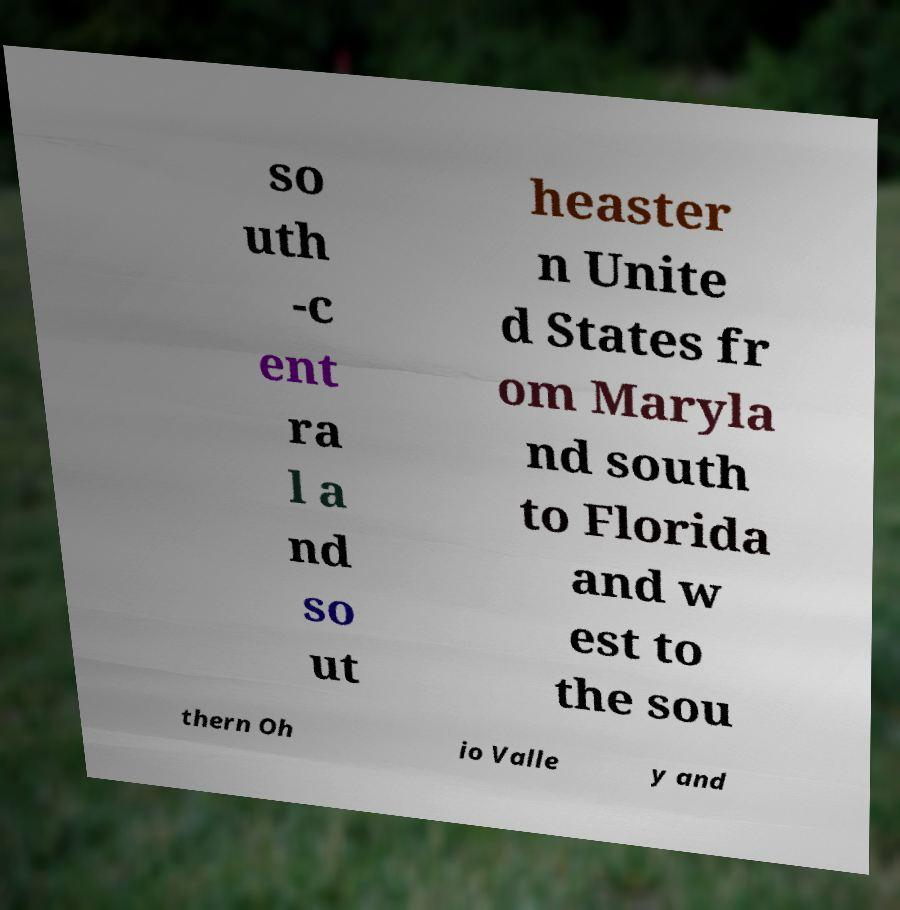What messages or text are displayed in this image? I need them in a readable, typed format. so uth -c ent ra l a nd so ut heaster n Unite d States fr om Maryla nd south to Florida and w est to the sou thern Oh io Valle y and 